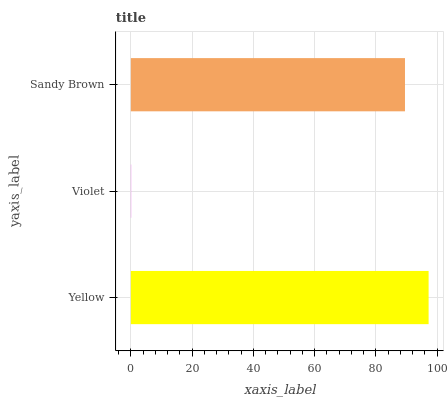Is Violet the minimum?
Answer yes or no. Yes. Is Yellow the maximum?
Answer yes or no. Yes. Is Sandy Brown the minimum?
Answer yes or no. No. Is Sandy Brown the maximum?
Answer yes or no. No. Is Sandy Brown greater than Violet?
Answer yes or no. Yes. Is Violet less than Sandy Brown?
Answer yes or no. Yes. Is Violet greater than Sandy Brown?
Answer yes or no. No. Is Sandy Brown less than Violet?
Answer yes or no. No. Is Sandy Brown the high median?
Answer yes or no. Yes. Is Sandy Brown the low median?
Answer yes or no. Yes. Is Yellow the high median?
Answer yes or no. No. Is Violet the low median?
Answer yes or no. No. 